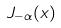<formula> <loc_0><loc_0><loc_500><loc_500>J _ { - \alpha } ( x )</formula> 